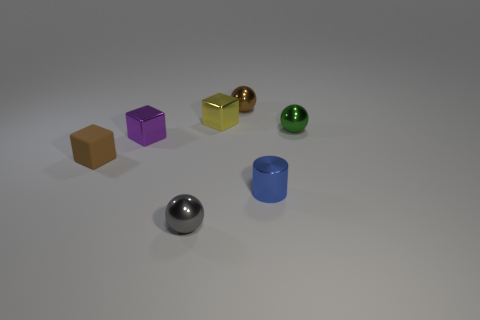Which object stands out the most to you and why? The gold cube stands out due to its shiny surface and distinct color, which contrasts with the subtler hues and textures of the other objects. What could be a practical use for the gold cube? Practically, it could serve as a paperweight or a decorative desk object, adding a touch of elegance and style to a workspace. 